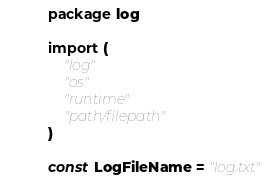Convert code to text. <code><loc_0><loc_0><loc_500><loc_500><_Go_>package log

import (
	"log"
	"os"
	"runtime"
	"path/filepath"
)

const LogFileName = "log.txt"
</code> 